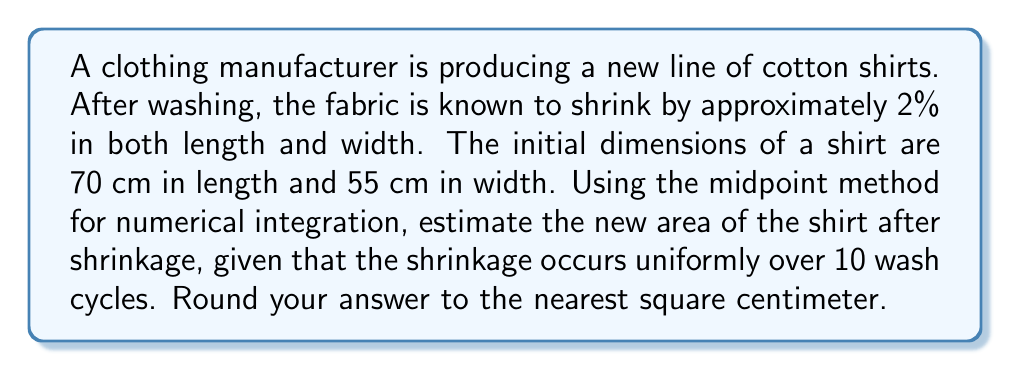Can you solve this math problem? To solve this problem, we'll use the midpoint method for numerical integration to estimate the new area of the shirt after shrinkage. Let's break it down step by step:

1) Initial dimensions:
   Length (L) = 70 cm
   Width (W) = 55 cm
   Initial Area = 70 * 55 = 3850 cm²

2) Shrinkage rate:
   2% = 0.02 per wash cycle

3) Number of wash cycles: 10

4) We need to calculate the new length and width after 10 wash cycles:
   
   For length: $L(t) = 70 * (1 - 0.02t)$
   For width: $W(t) = 55 * (1 - 0.02t)$
   
   Where t is the number of wash cycles (0 ≤ t ≤ 10)

5) The area after t wash cycles is:
   $A(t) = L(t) * W(t) = 70 * 55 * (1 - 0.02t)^2 = 3850 * (1 - 0.02t)^2$

6) To find the average area over the 10 wash cycles, we need to integrate this function from 0 to 10 and divide by 10:

   $\text{Average Area} = \frac{1}{10} \int_0^{10} 3850 * (1 - 0.02t)^2 dt$

7) Using the midpoint method with 10 subintervals:
   
   Interval width: $h = \frac{10 - 0}{10} = 1$
   Midpoints: $t_i = 0.5, 1.5, 2.5, ..., 9.5$

8) Apply the midpoint formula:

   $\text{Average Area} \approx \frac{1}{10} * \sum_{i=1}^{10} 3850 * (1 - 0.02t_i)^2 * 1$

9) Calculate this sum:
   
   $\frac{1}{10} * 3850 * [(1 - 0.02*0.5)^2 + (1 - 0.02*1.5)^2 + ... + (1 - 0.02*9.5)^2]$
   $= 385 * [0.9801 + 0.9409 + 0.9025 + 0.8649 + 0.8281 + 0.7921 + 0.7569 + 0.7225 + 0.6889 + 0.6561]$
   $= 385 * 8.133$
   $= 3131.205$ cm²

10) Round to the nearest square centimeter: 3131 cm²

This is our estimate for the new area of the shirt after shrinkage.
Answer: 3131 cm² 